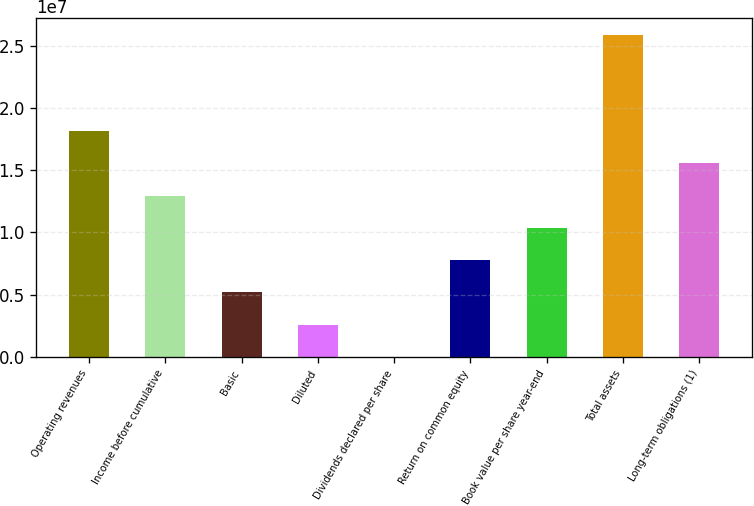Convert chart. <chart><loc_0><loc_0><loc_500><loc_500><bar_chart><fcel>Operating revenues<fcel>Income before cumulative<fcel>Basic<fcel>Diluted<fcel>Dividends declared per share<fcel>Return on common equity<fcel>Book value per share year-end<fcel>Total assets<fcel>Long-term obligations (1)<nl><fcel>1.81372e+07<fcel>1.29552e+07<fcel>5.18206e+06<fcel>2.59103e+06<fcel>1.28<fcel>7.77309e+06<fcel>1.03641e+07<fcel>2.59103e+07<fcel>1.55462e+07<nl></chart> 